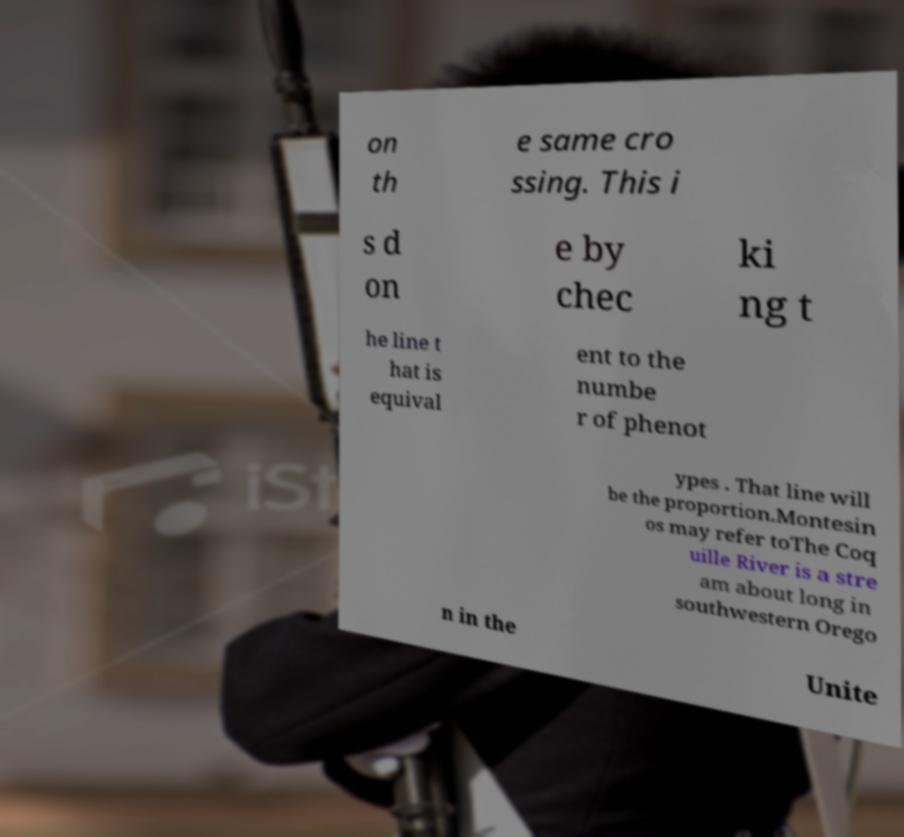There's text embedded in this image that I need extracted. Can you transcribe it verbatim? on th e same cro ssing. This i s d on e by chec ki ng t he line t hat is equival ent to the numbe r of phenot ypes . That line will be the proportion.Montesin os may refer toThe Coq uille River is a stre am about long in southwestern Orego n in the Unite 